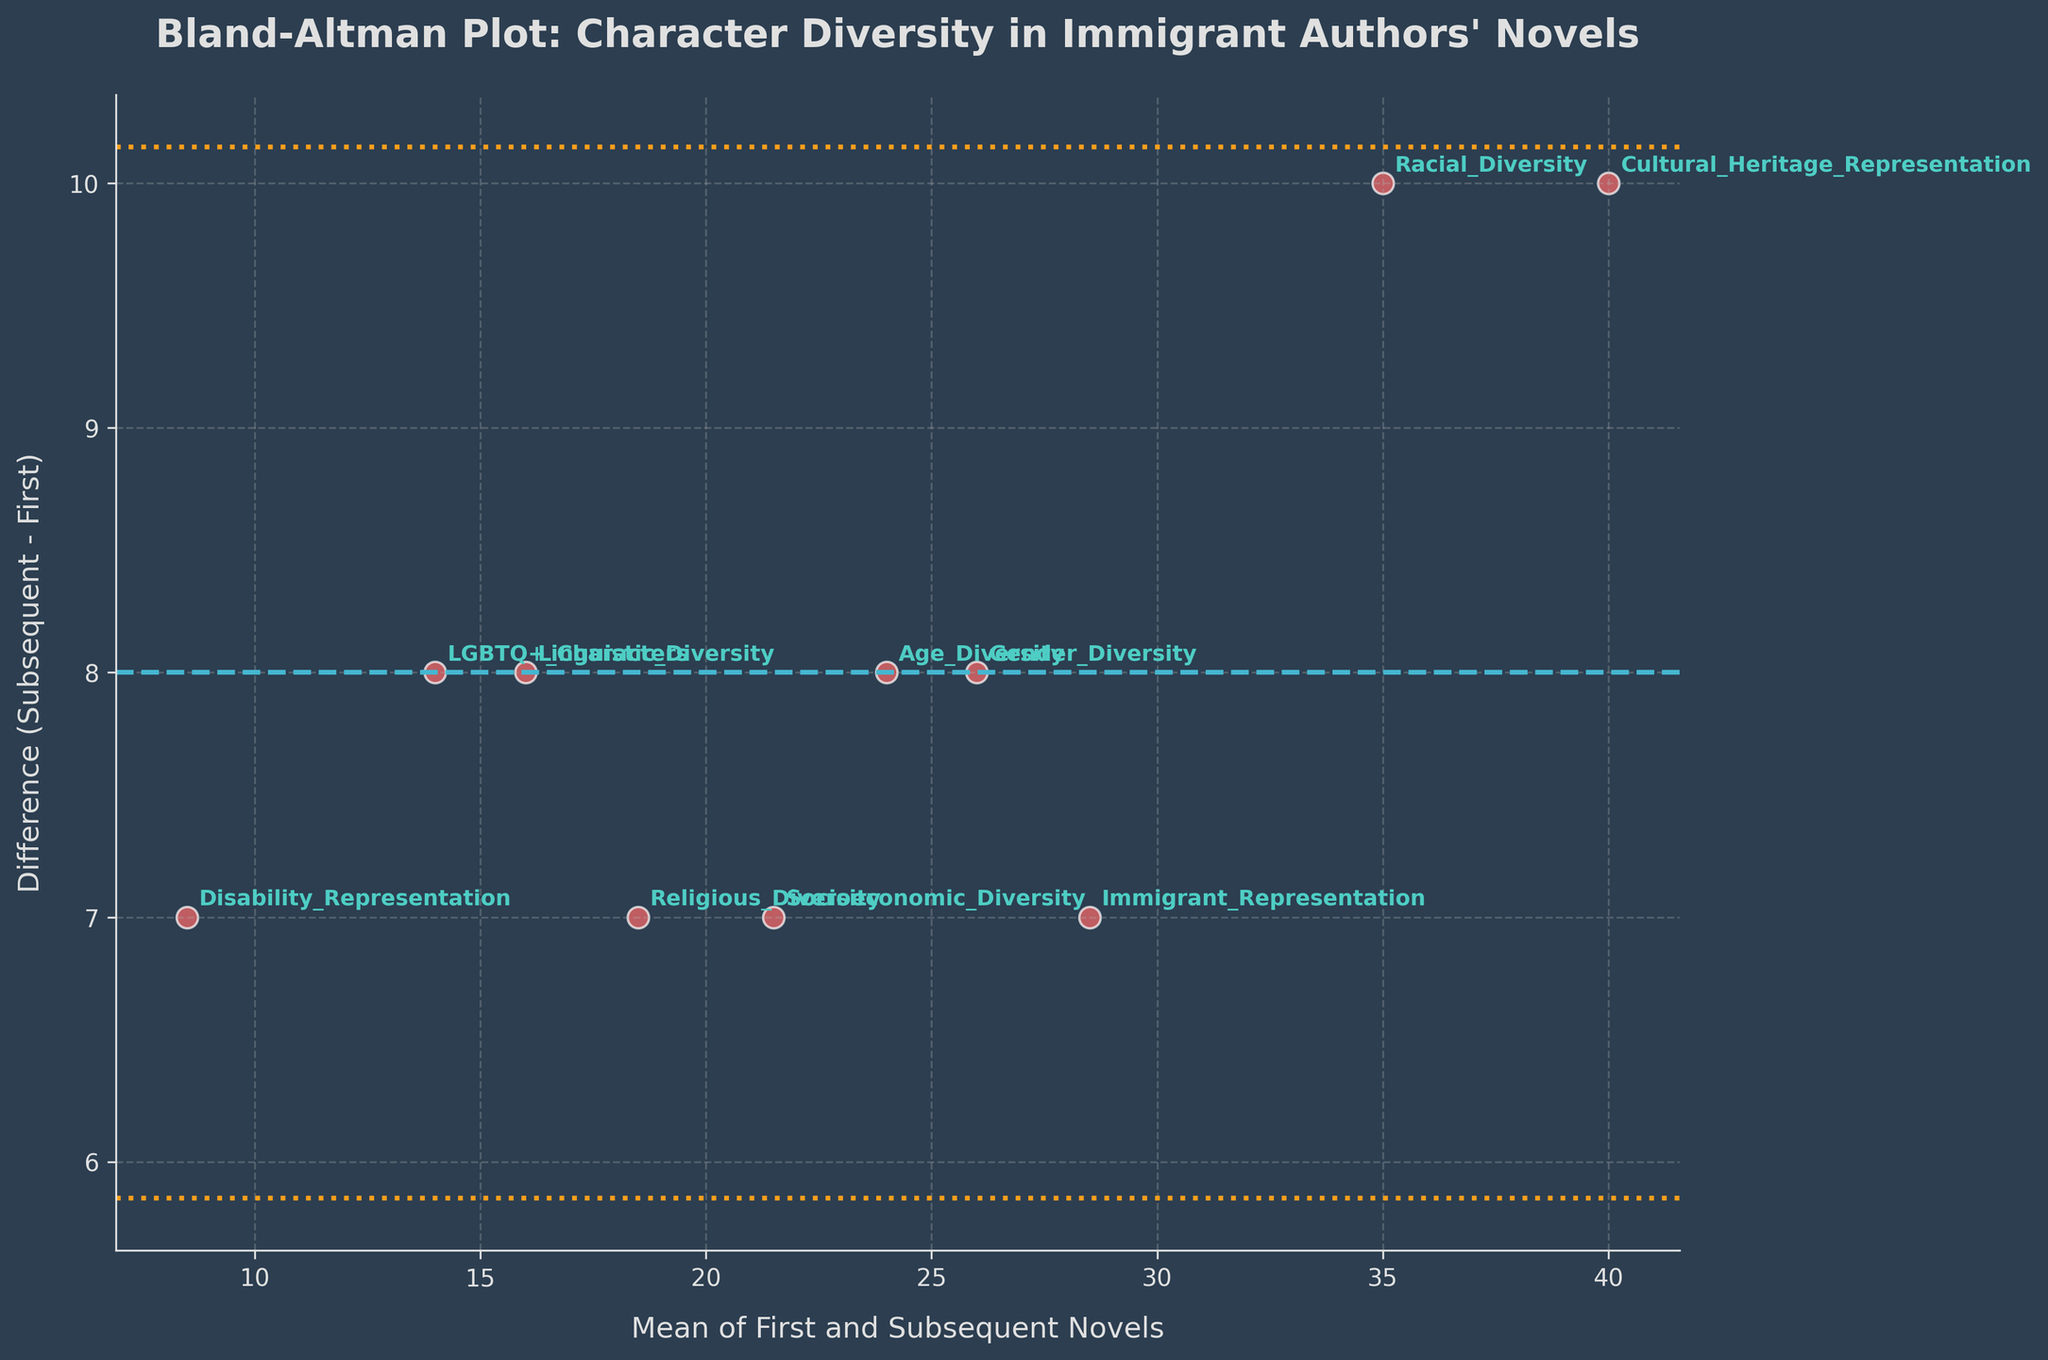How many types of character diversity are represented in the dataset? Look at the data points annotated on the Bland-Altman plot; each data point is labeled with a type of character diversity. Count the unique annotations.
Answer: 10 What is the title of the plot? The title is usually found at the top center of the plot.
Answer: Bland-Altman Plot: Character Diversity in Immigrant Authors’ Novels What is the average difference between the subsequent and first novels for all character diversity types? Calculate the differences for each diversity type, then find their average: (32-25 + 18-10 + 40-30 + 12-5 + 22-15 + 28-20 + 25-18 + 45-35 + 30-22 + 20-12) / 10 = 7.2
Answer: 7.2 Which character diversity has the largest positive difference between subsequent and first novels? Identify the data point with the highest difference on the y-axis, confirmed by its annotation.
Answer: Disability Representation On average, do subsequent novels have higher or lower character diversity representation than first novels? Compare the mean difference line indicated by the dashed line on the plot. If the average line is above zero, subsequent novels have higher representation.
Answer: Higher Which character diversity type shows the smallest change in representation between first and subsequent novels? Identify the data point closest to the zero line on the y-axis, confirmed by its annotation.
Answer: Racial Diversity What do the dotted lines in the plot represent? The dotted lines are at ±1.96 times the standard deviation of the differences, indicating limits of agreement.
Answer: Limits of Agreement Are there any character diversity types where subsequent novels have less representation than first novels? Look for data points below the zero line on the y-axis; if there are none, subsequent novels all have higher or equal representation.
Answer: No What is the mean value of the first and subsequent novels' societal and cultural diversity? Calculate the mean value for Socioeconomic Diversity and Cultural Heritage Representation: [(18+25)/2 + (35+45)/2] / 2 = [(21.5) + (40)] / 2 = 30.75
Answer: 30.75 